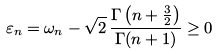Convert formula to latex. <formula><loc_0><loc_0><loc_500><loc_500>\varepsilon _ { n } = \omega _ { n } - \sqrt { 2 } \, \frac { \Gamma \left ( n + \frac { 3 } { 2 } \right ) } { \Gamma ( n + 1 ) } \geq 0</formula> 